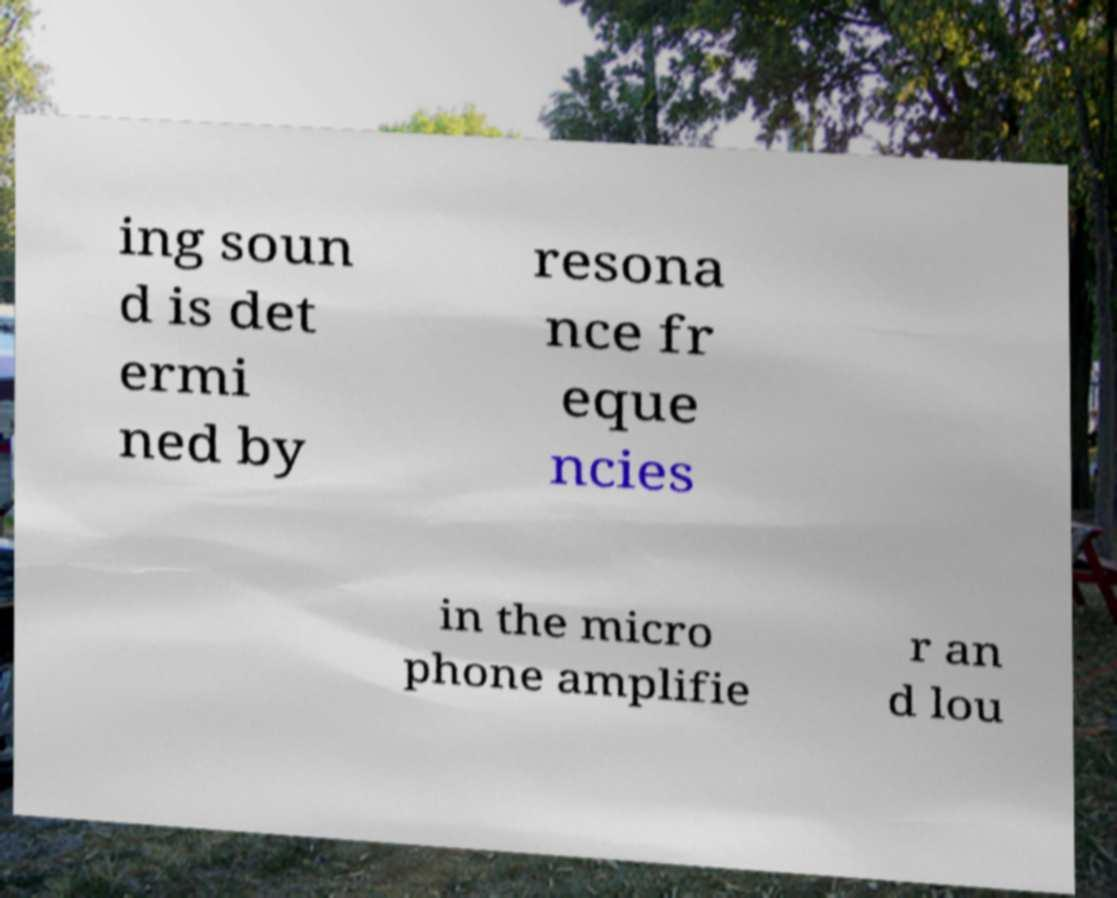Can you accurately transcribe the text from the provided image for me? ing soun d is det ermi ned by resona nce fr eque ncies in the micro phone amplifie r an d lou 